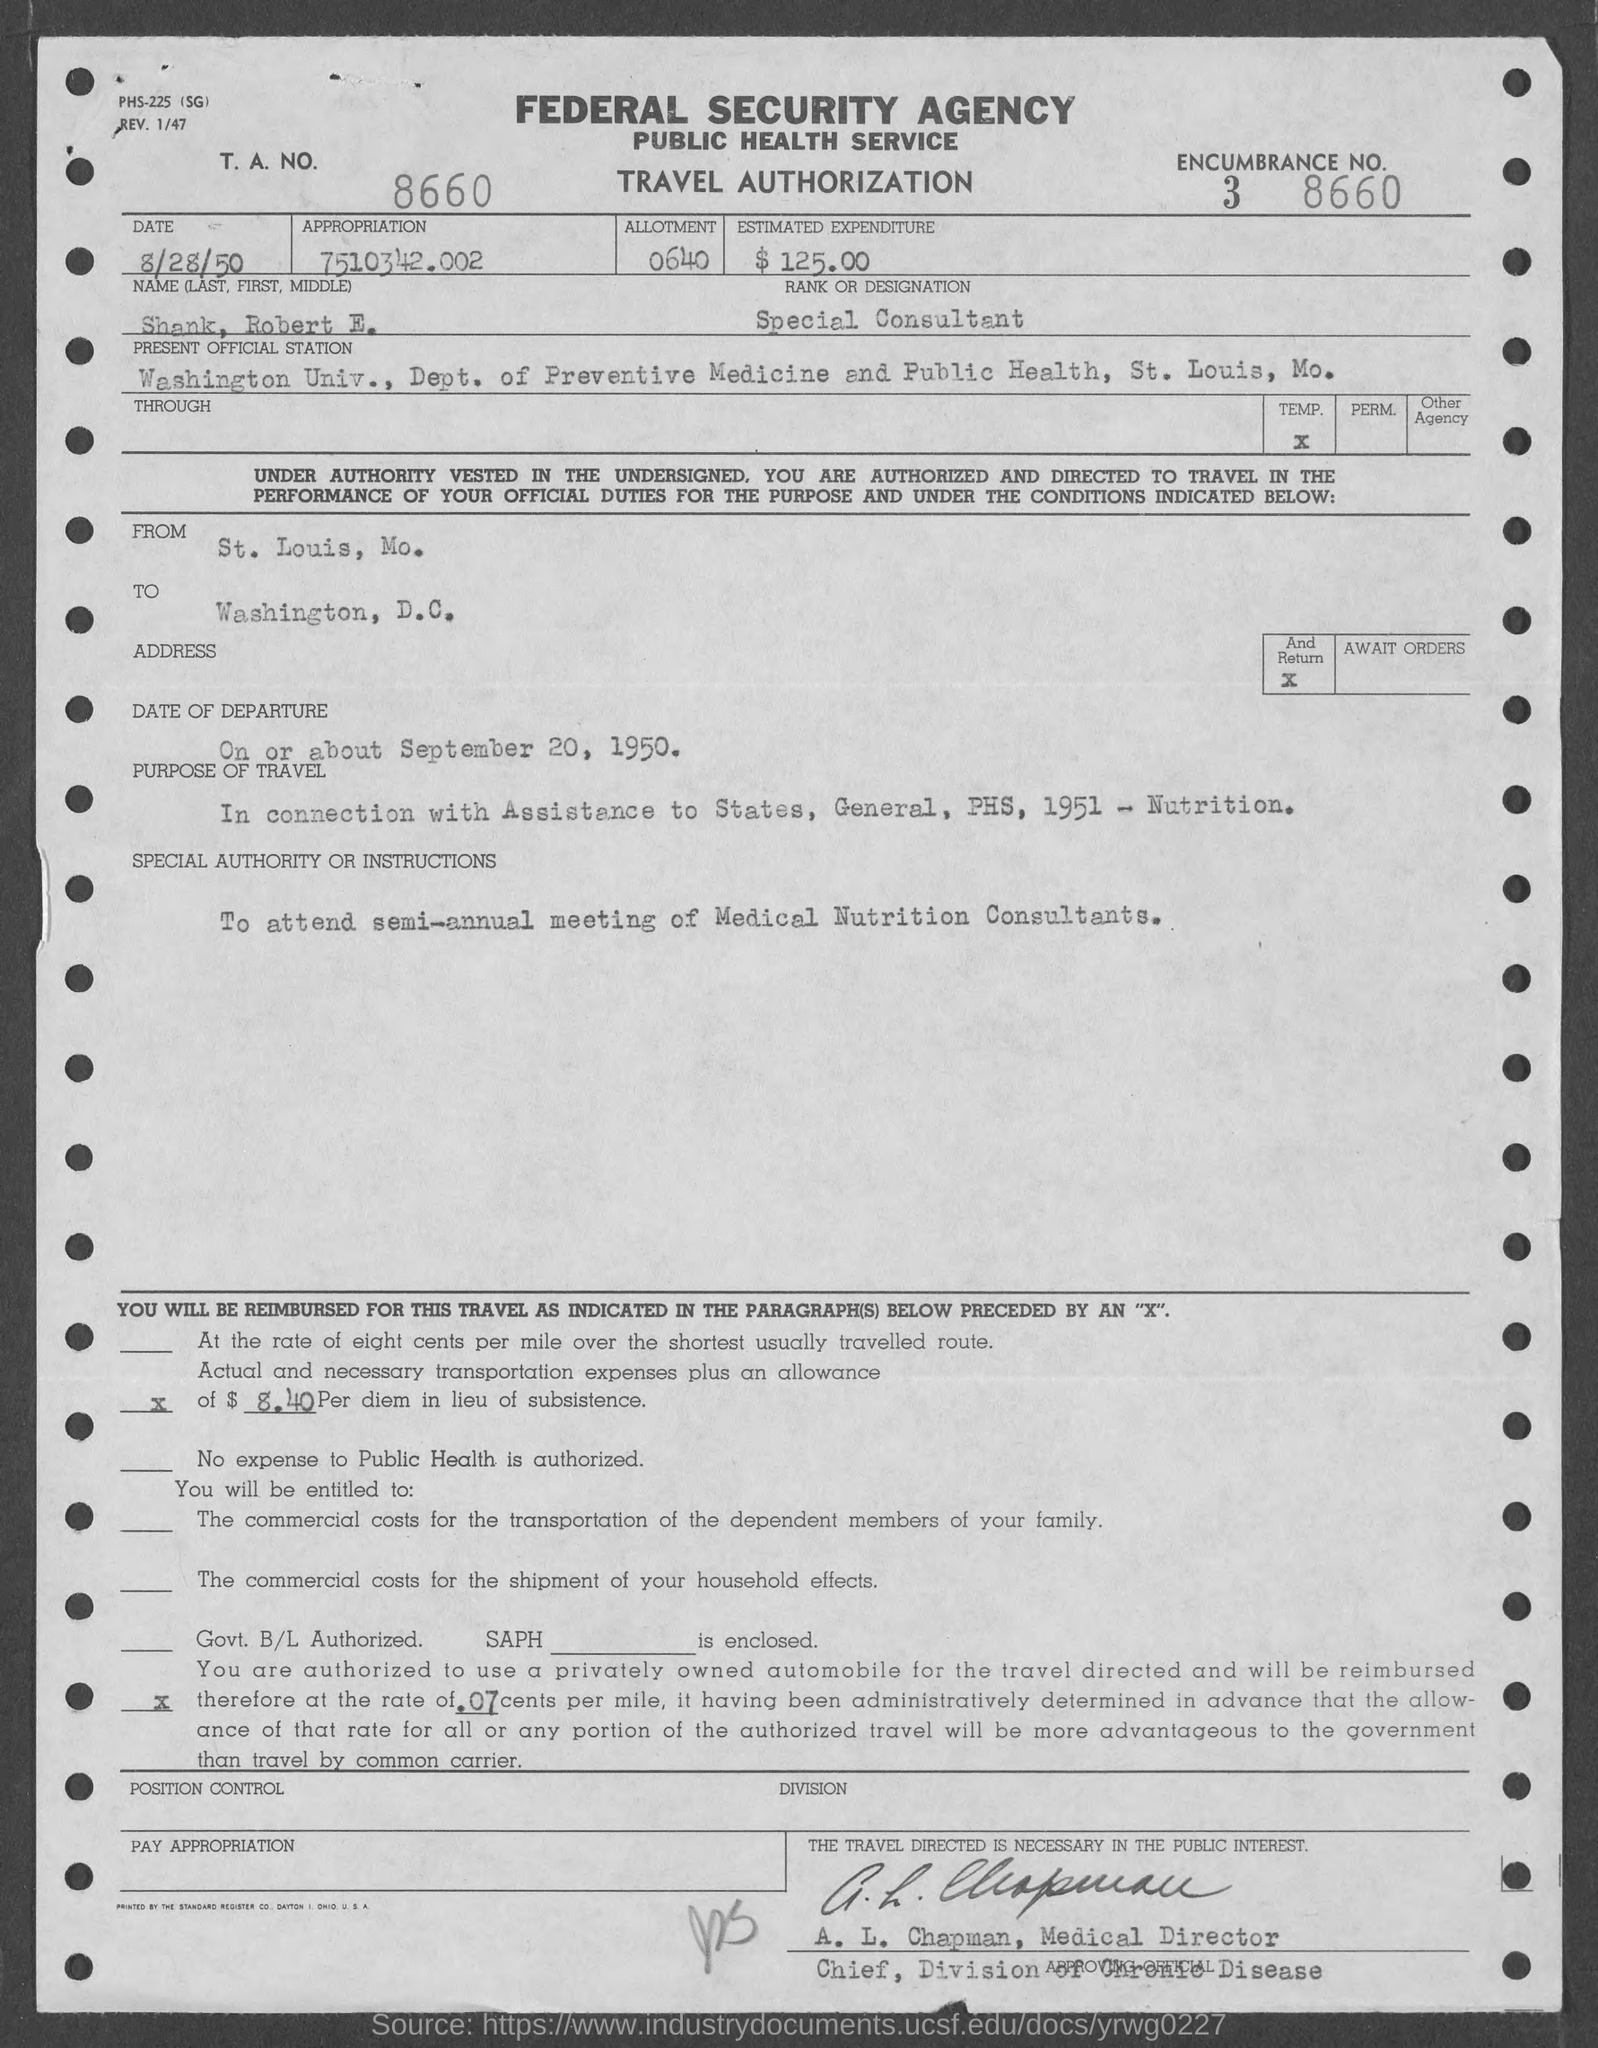What is ENCUMBERANCE Number ?
Your response must be concise. 3 8660. What is the Allotment  Number ?
Offer a terse response. 0640. What is the date mentioned in the top of the document ?
Your answer should be very brief. 8/28/50. How much Estimated Expenditure ?
Your response must be concise. $125.00. What is the Designation of Shank ?
Your answer should be compact. Special Consultant. 